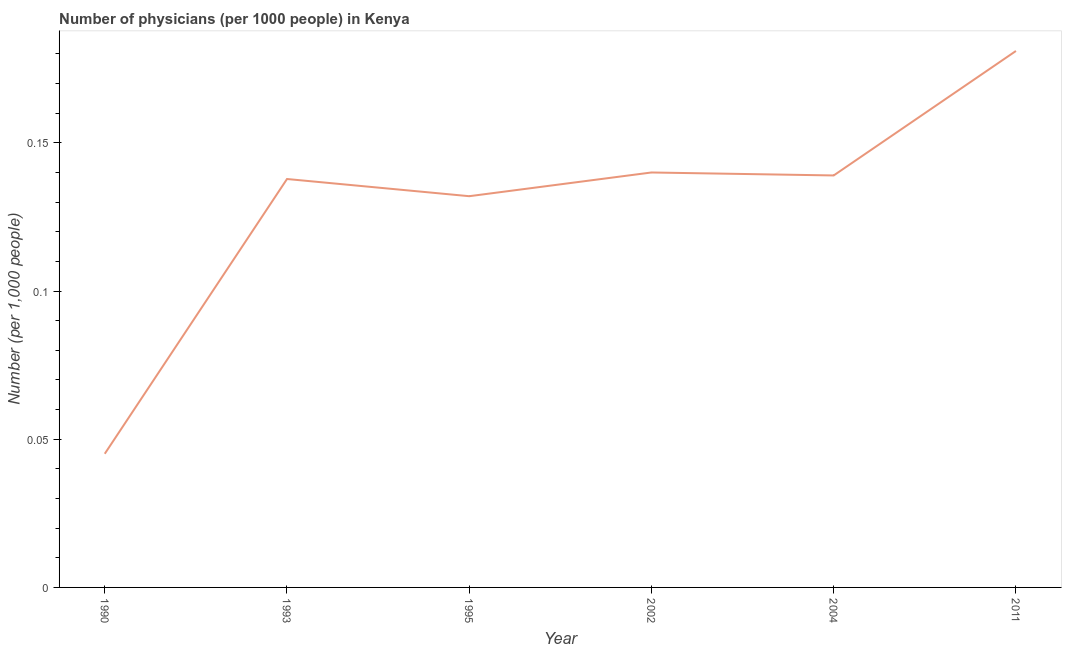What is the number of physicians in 1995?
Your answer should be compact. 0.13. Across all years, what is the maximum number of physicians?
Offer a terse response. 0.18. Across all years, what is the minimum number of physicians?
Offer a terse response. 0.05. In which year was the number of physicians minimum?
Provide a succinct answer. 1990. What is the sum of the number of physicians?
Offer a very short reply. 0.77. What is the difference between the number of physicians in 2002 and 2011?
Your answer should be very brief. -0.04. What is the average number of physicians per year?
Offer a terse response. 0.13. What is the median number of physicians?
Provide a succinct answer. 0.14. In how many years, is the number of physicians greater than 0.15000000000000002 ?
Give a very brief answer. 1. What is the ratio of the number of physicians in 1995 to that in 2004?
Your response must be concise. 0.95. Is the difference between the number of physicians in 1990 and 2002 greater than the difference between any two years?
Your response must be concise. No. What is the difference between the highest and the second highest number of physicians?
Give a very brief answer. 0.04. Is the sum of the number of physicians in 1993 and 2011 greater than the maximum number of physicians across all years?
Give a very brief answer. Yes. What is the difference between the highest and the lowest number of physicians?
Your answer should be very brief. 0.14. How many lines are there?
Provide a short and direct response. 1. What is the difference between two consecutive major ticks on the Y-axis?
Make the answer very short. 0.05. Does the graph contain any zero values?
Your answer should be compact. No. Does the graph contain grids?
Keep it short and to the point. No. What is the title of the graph?
Ensure brevity in your answer.  Number of physicians (per 1000 people) in Kenya. What is the label or title of the Y-axis?
Offer a very short reply. Number (per 1,0 people). What is the Number (per 1,000 people) of 1990?
Your answer should be very brief. 0.05. What is the Number (per 1,000 people) in 1993?
Offer a terse response. 0.14. What is the Number (per 1,000 people) in 1995?
Your answer should be compact. 0.13. What is the Number (per 1,000 people) of 2002?
Give a very brief answer. 0.14. What is the Number (per 1,000 people) of 2004?
Your answer should be compact. 0.14. What is the Number (per 1,000 people) in 2011?
Your answer should be very brief. 0.18. What is the difference between the Number (per 1,000 people) in 1990 and 1993?
Make the answer very short. -0.09. What is the difference between the Number (per 1,000 people) in 1990 and 1995?
Offer a terse response. -0.09. What is the difference between the Number (per 1,000 people) in 1990 and 2002?
Make the answer very short. -0.09. What is the difference between the Number (per 1,000 people) in 1990 and 2004?
Your answer should be compact. -0.09. What is the difference between the Number (per 1,000 people) in 1990 and 2011?
Provide a short and direct response. -0.14. What is the difference between the Number (per 1,000 people) in 1993 and 1995?
Your response must be concise. 0.01. What is the difference between the Number (per 1,000 people) in 1993 and 2002?
Your answer should be very brief. -0. What is the difference between the Number (per 1,000 people) in 1993 and 2004?
Provide a short and direct response. -0. What is the difference between the Number (per 1,000 people) in 1993 and 2011?
Your answer should be very brief. -0.04. What is the difference between the Number (per 1,000 people) in 1995 and 2002?
Your answer should be very brief. -0.01. What is the difference between the Number (per 1,000 people) in 1995 and 2004?
Offer a very short reply. -0.01. What is the difference between the Number (per 1,000 people) in 1995 and 2011?
Your answer should be compact. -0.05. What is the difference between the Number (per 1,000 people) in 2002 and 2004?
Offer a very short reply. 0. What is the difference between the Number (per 1,000 people) in 2002 and 2011?
Offer a terse response. -0.04. What is the difference between the Number (per 1,000 people) in 2004 and 2011?
Your answer should be compact. -0.04. What is the ratio of the Number (per 1,000 people) in 1990 to that in 1993?
Ensure brevity in your answer.  0.33. What is the ratio of the Number (per 1,000 people) in 1990 to that in 1995?
Make the answer very short. 0.34. What is the ratio of the Number (per 1,000 people) in 1990 to that in 2002?
Your response must be concise. 0.32. What is the ratio of the Number (per 1,000 people) in 1990 to that in 2004?
Your response must be concise. 0.32. What is the ratio of the Number (per 1,000 people) in 1990 to that in 2011?
Offer a very short reply. 0.25. What is the ratio of the Number (per 1,000 people) in 1993 to that in 1995?
Provide a short and direct response. 1.04. What is the ratio of the Number (per 1,000 people) in 1993 to that in 2004?
Keep it short and to the point. 0.99. What is the ratio of the Number (per 1,000 people) in 1993 to that in 2011?
Give a very brief answer. 0.76. What is the ratio of the Number (per 1,000 people) in 1995 to that in 2002?
Your answer should be very brief. 0.94. What is the ratio of the Number (per 1,000 people) in 1995 to that in 2004?
Offer a very short reply. 0.95. What is the ratio of the Number (per 1,000 people) in 1995 to that in 2011?
Your answer should be very brief. 0.73. What is the ratio of the Number (per 1,000 people) in 2002 to that in 2011?
Your answer should be very brief. 0.77. What is the ratio of the Number (per 1,000 people) in 2004 to that in 2011?
Offer a very short reply. 0.77. 